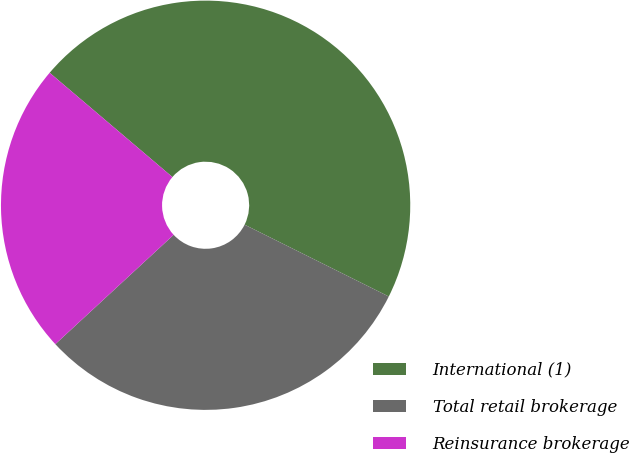Convert chart to OTSL. <chart><loc_0><loc_0><loc_500><loc_500><pie_chart><fcel>International (1)<fcel>Total retail brokerage<fcel>Reinsurance brokerage<nl><fcel>46.15%<fcel>30.77%<fcel>23.08%<nl></chart> 